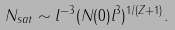<formula> <loc_0><loc_0><loc_500><loc_500>N _ { s a t } \sim l ^ { - 3 } ( N ( 0 ) l ^ { 3 } ) ^ { 1 / ( Z + 1 ) } .</formula> 